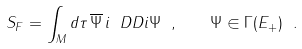<formula> <loc_0><loc_0><loc_500><loc_500>S _ { F } = \int _ { M } d \tau \, \overline { \Psi } \, i \ D D i \Psi \ , \quad \Psi \in \Gamma ( E _ { + } ) \ .</formula> 